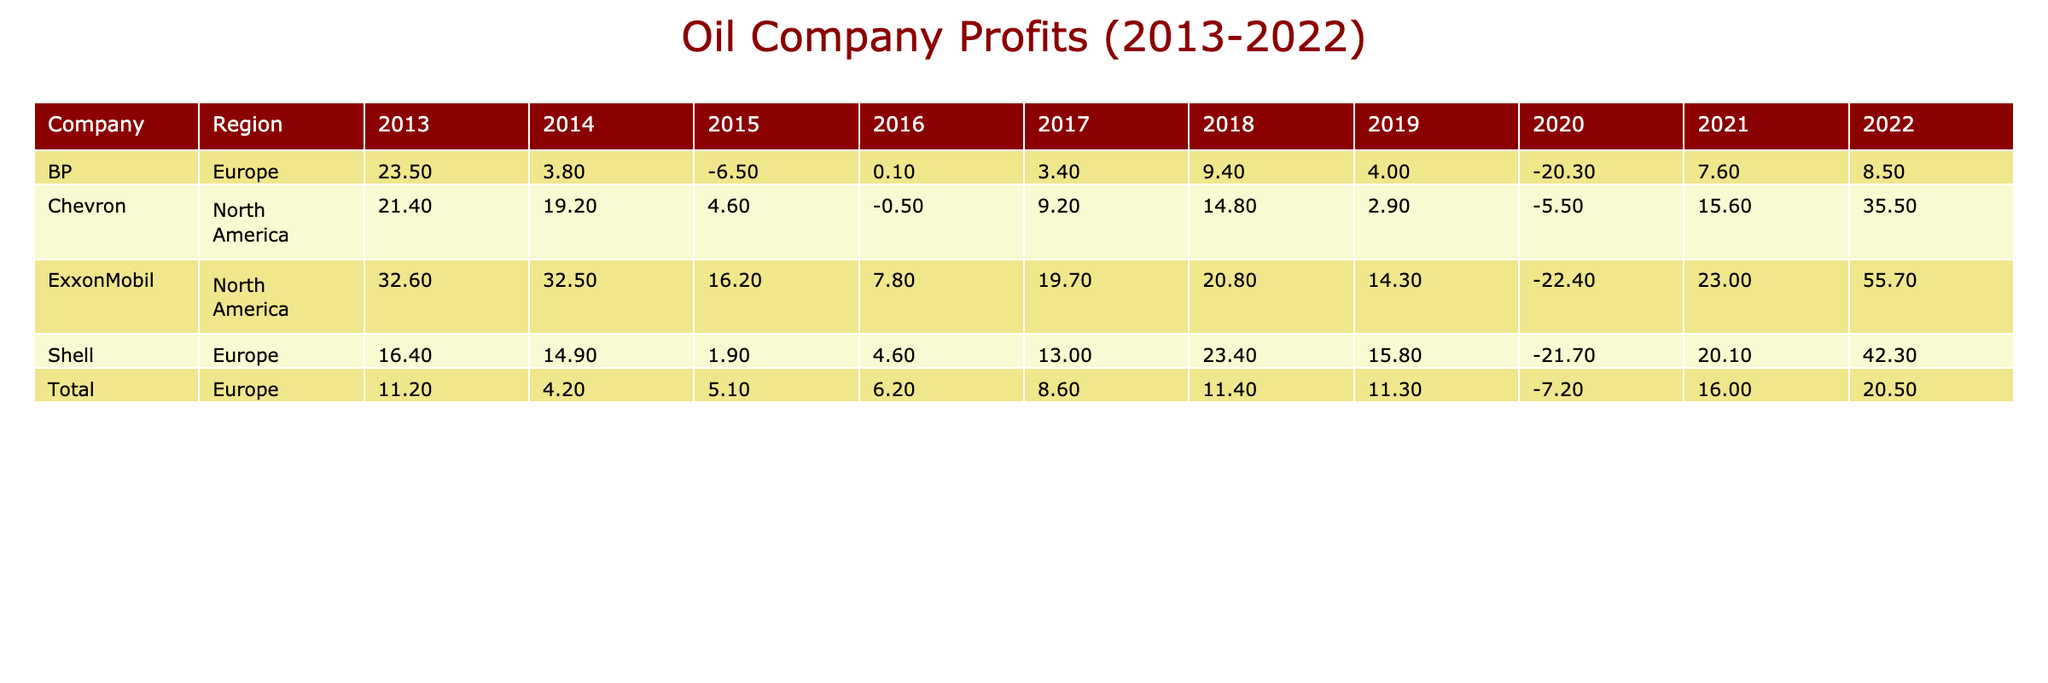What was ExxonMobil's profit in 2022? Looking at the table, for ExxonMobil in the year 2022, the profit is listed as 55.7 billion USD.
Answer: 55.7 billion USD What was the year with the highest profit for Chevron? By inspecting the profit values for Chevron throughout the years, 2022 shows the highest profit at 35.5 billion USD.
Answer: 2022 What is the total profit for BP from 2013 to 2022? To find BP's total profit, we add the profits from each year: 23.5 + 3.8 - 6.5 + 0.1 + 3.4 + 9.4 + 4.0 - 20.3 + 7.6 + 8.5 = 33.1 billion USD.
Answer: 33.1 billion USD Did Shell have a positive profit in 2020? Checking the profit value for Shell in 2020, it is -21.7 billion USD, which indicates a loss. Therefore, the answer is no.
Answer: No Which company had the highest profit in 2021? Analyzing the table for all the companies in 2021, ExxonMobil shows a profit of 23.0 billion USD, while Chevron made 15.6 billion USD, BP made 7.6 billion USD, and Shell made 20.1 billion USD. Thus, ExxonMobil had the highest profit.
Answer: ExxonMobil What was the average profit for Total from 2013 to 2022? To calculate the average for Total, we sum the profits for each year: 11.2 + 4.2 + 5.1 + 6.2 + 8.6 + 11.4 + 11.3 - 7.2 + 16.0 + 20.5 = 77.1 billion USD. There are 10 years, so the average profit is 77.1 / 10 = 7.71 billion USD.
Answer: 7.71 billion USD In which year did ExxonMobil experience a loss? Reviewing the profit entries for ExxonMobil, the year 2020 shows a profit of -22.4 billion USD. Therefore, that is the year of loss.
Answer: 2020 What was Shell's profit difference between 2022 and 2013? To find the difference in profit, we take Shell's profit in 2022 (42.3 billion) and subtract the profit in 2013 (16.4 billion). The difference is 42.3 - 16.4 = 25.9 billion USD.
Answer: 25.9 billion USD Was Total consistently profitable from 2013 to 2022? Checking each year's profit, Total experienced a loss in 2020 (-7.2 billion USD). This indicates that Total was not consistently profitable throughout the period.
Answer: No 